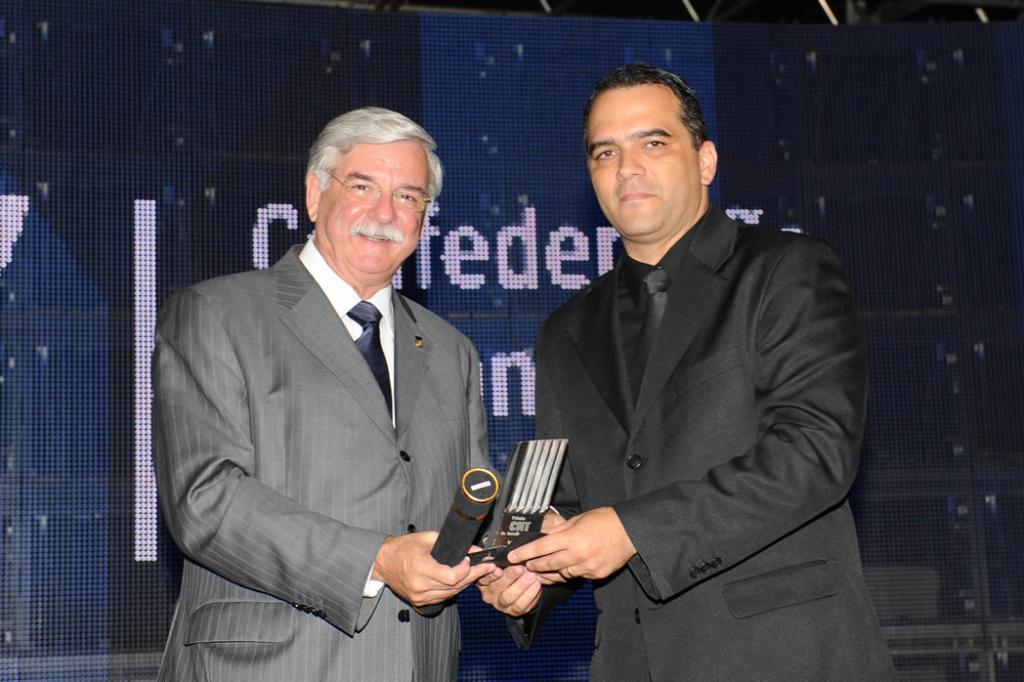How many people are in the image? There are two persons standing in the image. What is one person holding in the image? One person is holding a trophy. What is the other person holding in the image? The other person is holding an item. What can be seen in the background of the image? There is a board visible in the background of the image. What type of waves can be seen crashing on the shore in the image? There are no waves or shore visible in the image; it features two people and a board in the background. What historical event is being commemorated in the image? There is no indication of a historical event being commemorated in the image. 